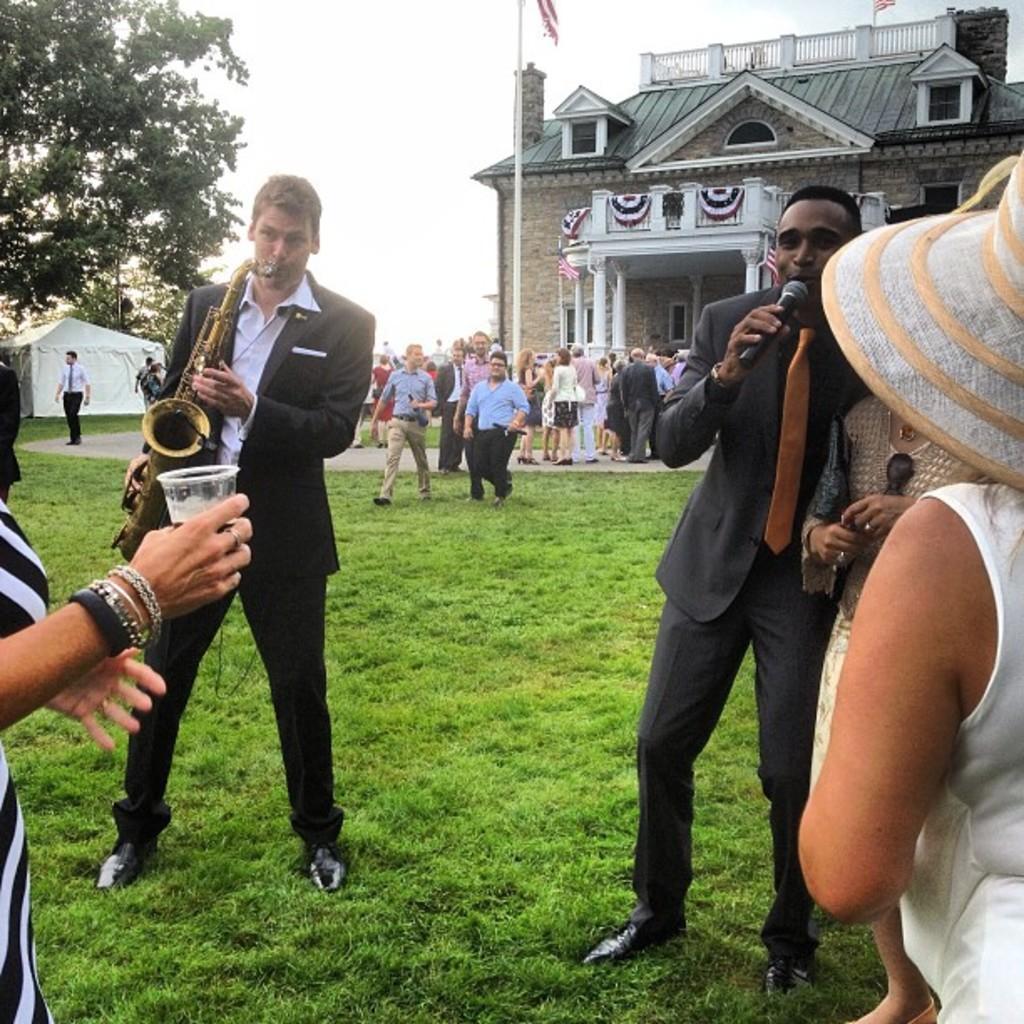Could you give a brief overview of what you see in this image? This picture shows a building and we see few people standing and couple of them holding microphones in their hands and man singing and we see a another man holding a saxophone and playing it and we see a woman holding a glass in her hand and we see grass on the ground and a flag pole and we see trees and a cloudy Sky and we see a woman wore a hat on her head. 